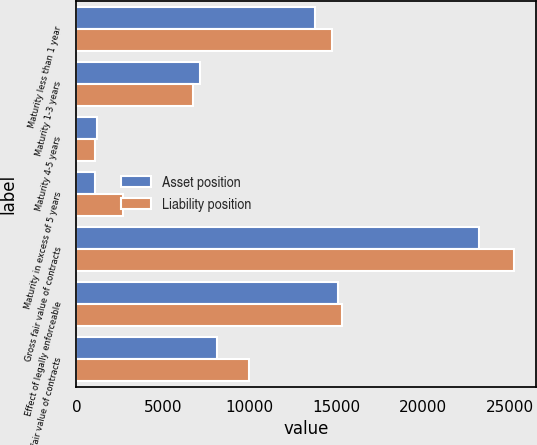Convert chart. <chart><loc_0><loc_0><loc_500><loc_500><stacked_bar_chart><ecel><fcel>Maturity less than 1 year<fcel>Maturity 1-3 years<fcel>Maturity 4-5 years<fcel>Maturity in excess of 5 years<fcel>Gross fair value of contracts<fcel>Effect of legally enforceable<fcel>Net fair value of contracts<nl><fcel>Asset position<fcel>13750<fcel>7155<fcel>1214<fcel>1091<fcel>23210<fcel>15082<fcel>8128<nl><fcel>Liability position<fcel>14766<fcel>6733<fcel>1048<fcel>2700<fcel>25247<fcel>15318<fcel>9929<nl></chart> 